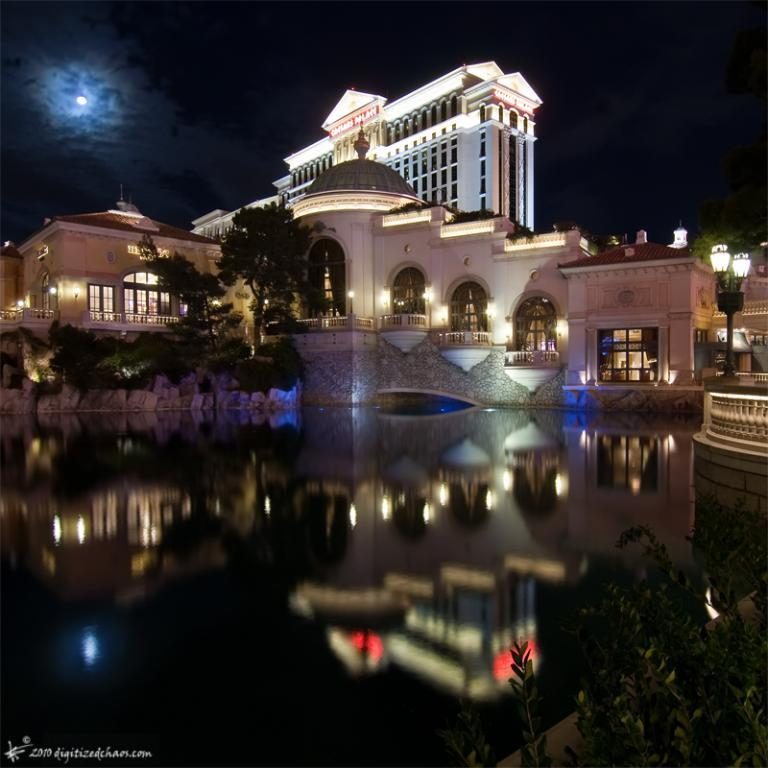What type of structures can be seen in the image? There are buildings in the image. What natural element is visible in the image? There is water visible in the image. What type of vegetation is present in the image? There are trees in the image. What type of lighting is present in the image? Pole lights are present in the image. What celestial body is visible in the sky? The moon is visible in the sky. Where is the text located in the image? The text is in the bottom left corner of the image. Can you tell me how many jellyfish are swimming in the water in the image? There are no jellyfish present in the image; it features buildings, water, trees, pole lights, the moon, and text. What type of plate is used to serve the food in the image? There is no food or plate present in the image. 